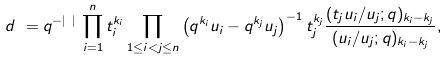<formula> <loc_0><loc_0><loc_500><loc_500>d _ { \mathbf k } = q ^ { - | { \mathbf k } | } \, \prod _ { i = 1 } ^ { n } t _ { i } ^ { k _ { i } } \prod _ { 1 \leq i < j \leq n } \left ( q ^ { k _ { i } } u _ { i } - q ^ { k _ { j } } u _ { j } \right ) ^ { - 1 } t _ { j } ^ { k _ { j } } \frac { ( t _ { j } u _ { i } / u _ { j } ; q ) _ { k _ { i } - k _ { j } } } { ( u _ { i } / u _ { j } ; q ) _ { k _ { i } - k _ { j } } } ,</formula> 